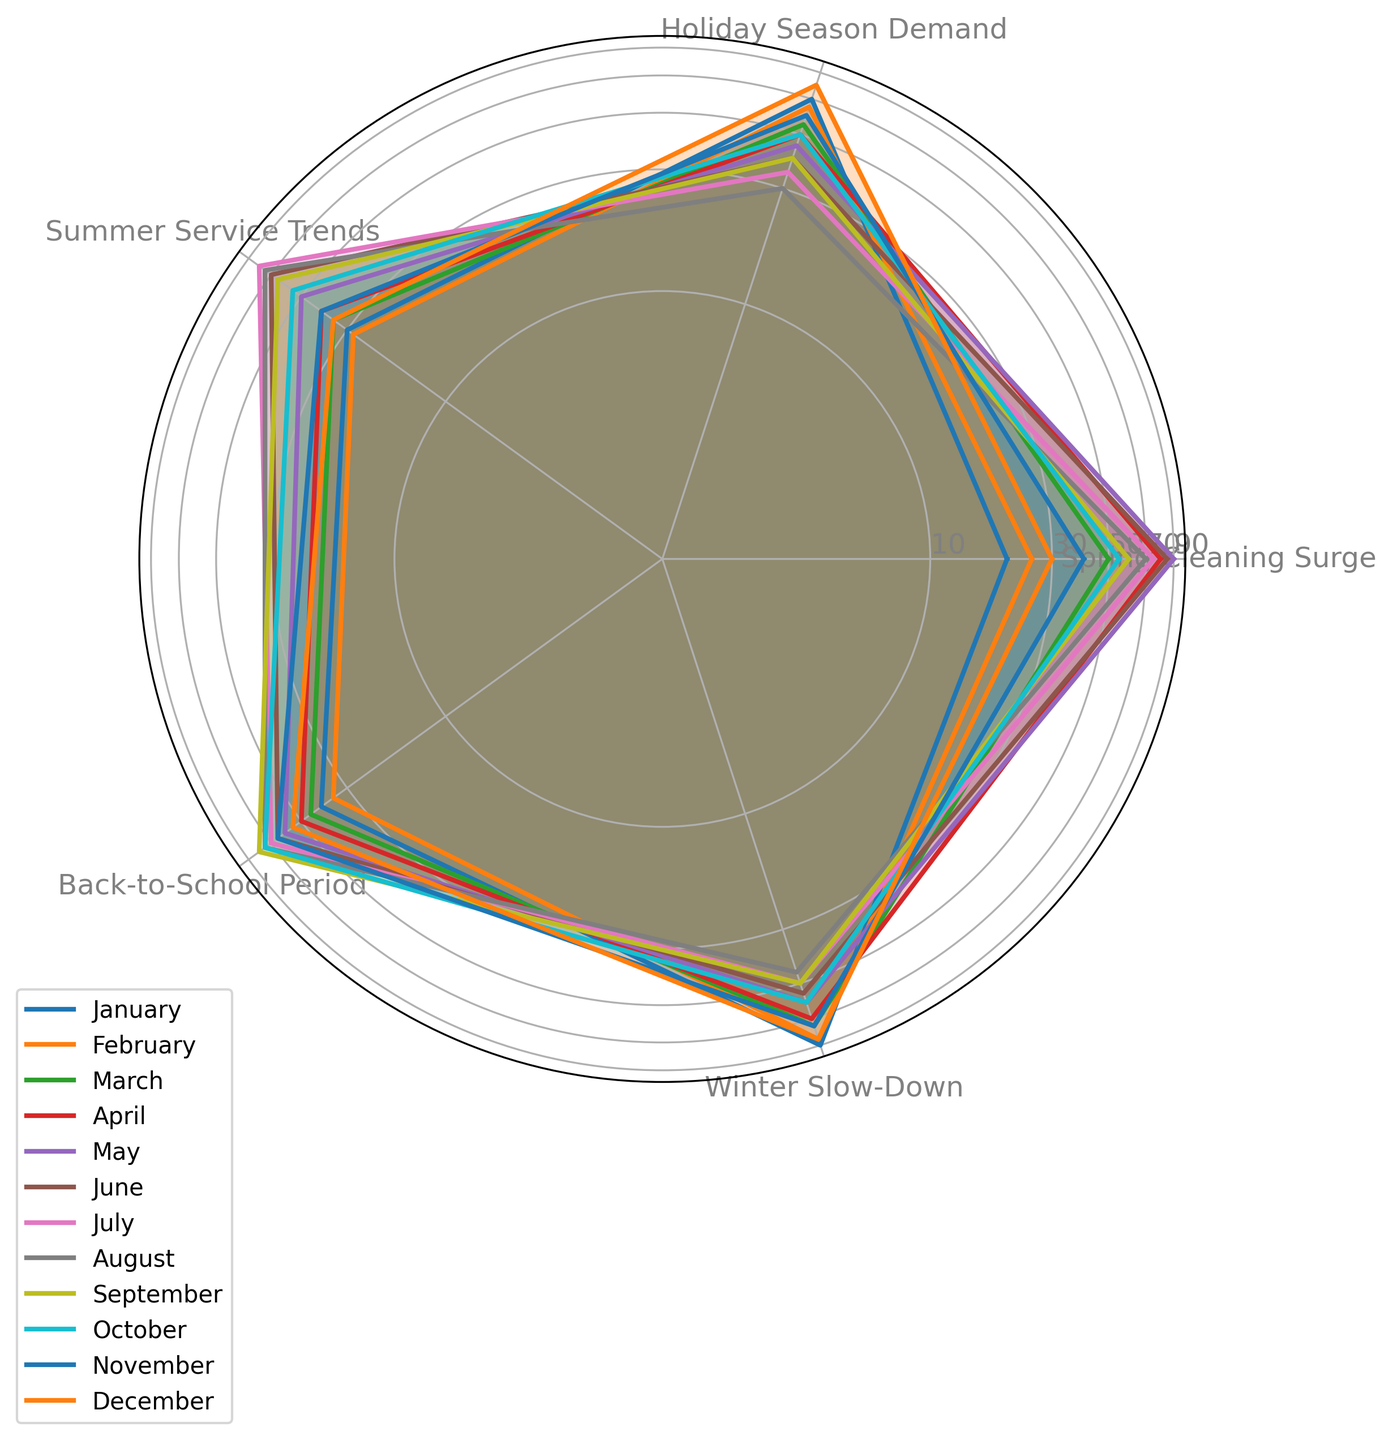Which season shows the highest demand during the Spring Cleaning Surge? First, locate the "Spring Cleaning Surge" axis in the figure. Each season's value is plotted along this axis. The highest point on the axis indicates which season has the highest demand for spring cleaning.
Answer: May Which season has the lowest demand during the Winter Slow-Down? Locate the "Winter Slow-Down" axis. Then, find the season with the lowest point plotted along this axis.
Answer: August How does the demand for spring cleaning in April compare to March? Find the plotted values for both March and April on the "Spring Cleaning Surge" axis. Compare these values to determine which month has a higher demand.
Answer: April has higher demand During which season does the Back-to-School period have its peak demand? Identify the axis labeled "Back-to-School Period" and find the season that has the highest value plotted on this axis.
Answer: September What is the average demand value for Holiday Season in November and December? Locate the "Holiday Season Demand" axis. Find the value for both November and December, then calculate the average. The values are 60 and 80, respectively, so the average is (60 + 80) / 2 = 70.
Answer: 70 Which season has the closest demand values for both Summer Service Trends and Back-to-School Period? Look at the plotted values along the "Summer Service Trends" and "Back-to-School Period" axes for each season. Identify the season where these values are closest.
Answer: August Compare the trends of Winter Slow-Down in January and June. Which one has a higher value, and by how much? Find the values for January and June on the "Winter Slow-Down" axis. January has a value of 90, and June has a value of 55. Subtract 55 from 90 to find the difference.
Answer: January, by 35 What is the overall trend for Summer Service Trends from March to August? Observe the "Summer Service Trends" axis and follow the values from March to August. The values generally increase from 35 in March to 75 in August.
Answer: Increasing Which month shows a significant dip in demand across most categories compared to its neighboring months? Look across all categories for each month to identify any significant drops in multiple axes. Visually compare each month, paying close attention to overall drops. July shows a noticeable dip when looking at multiple axes.
Answer: July 